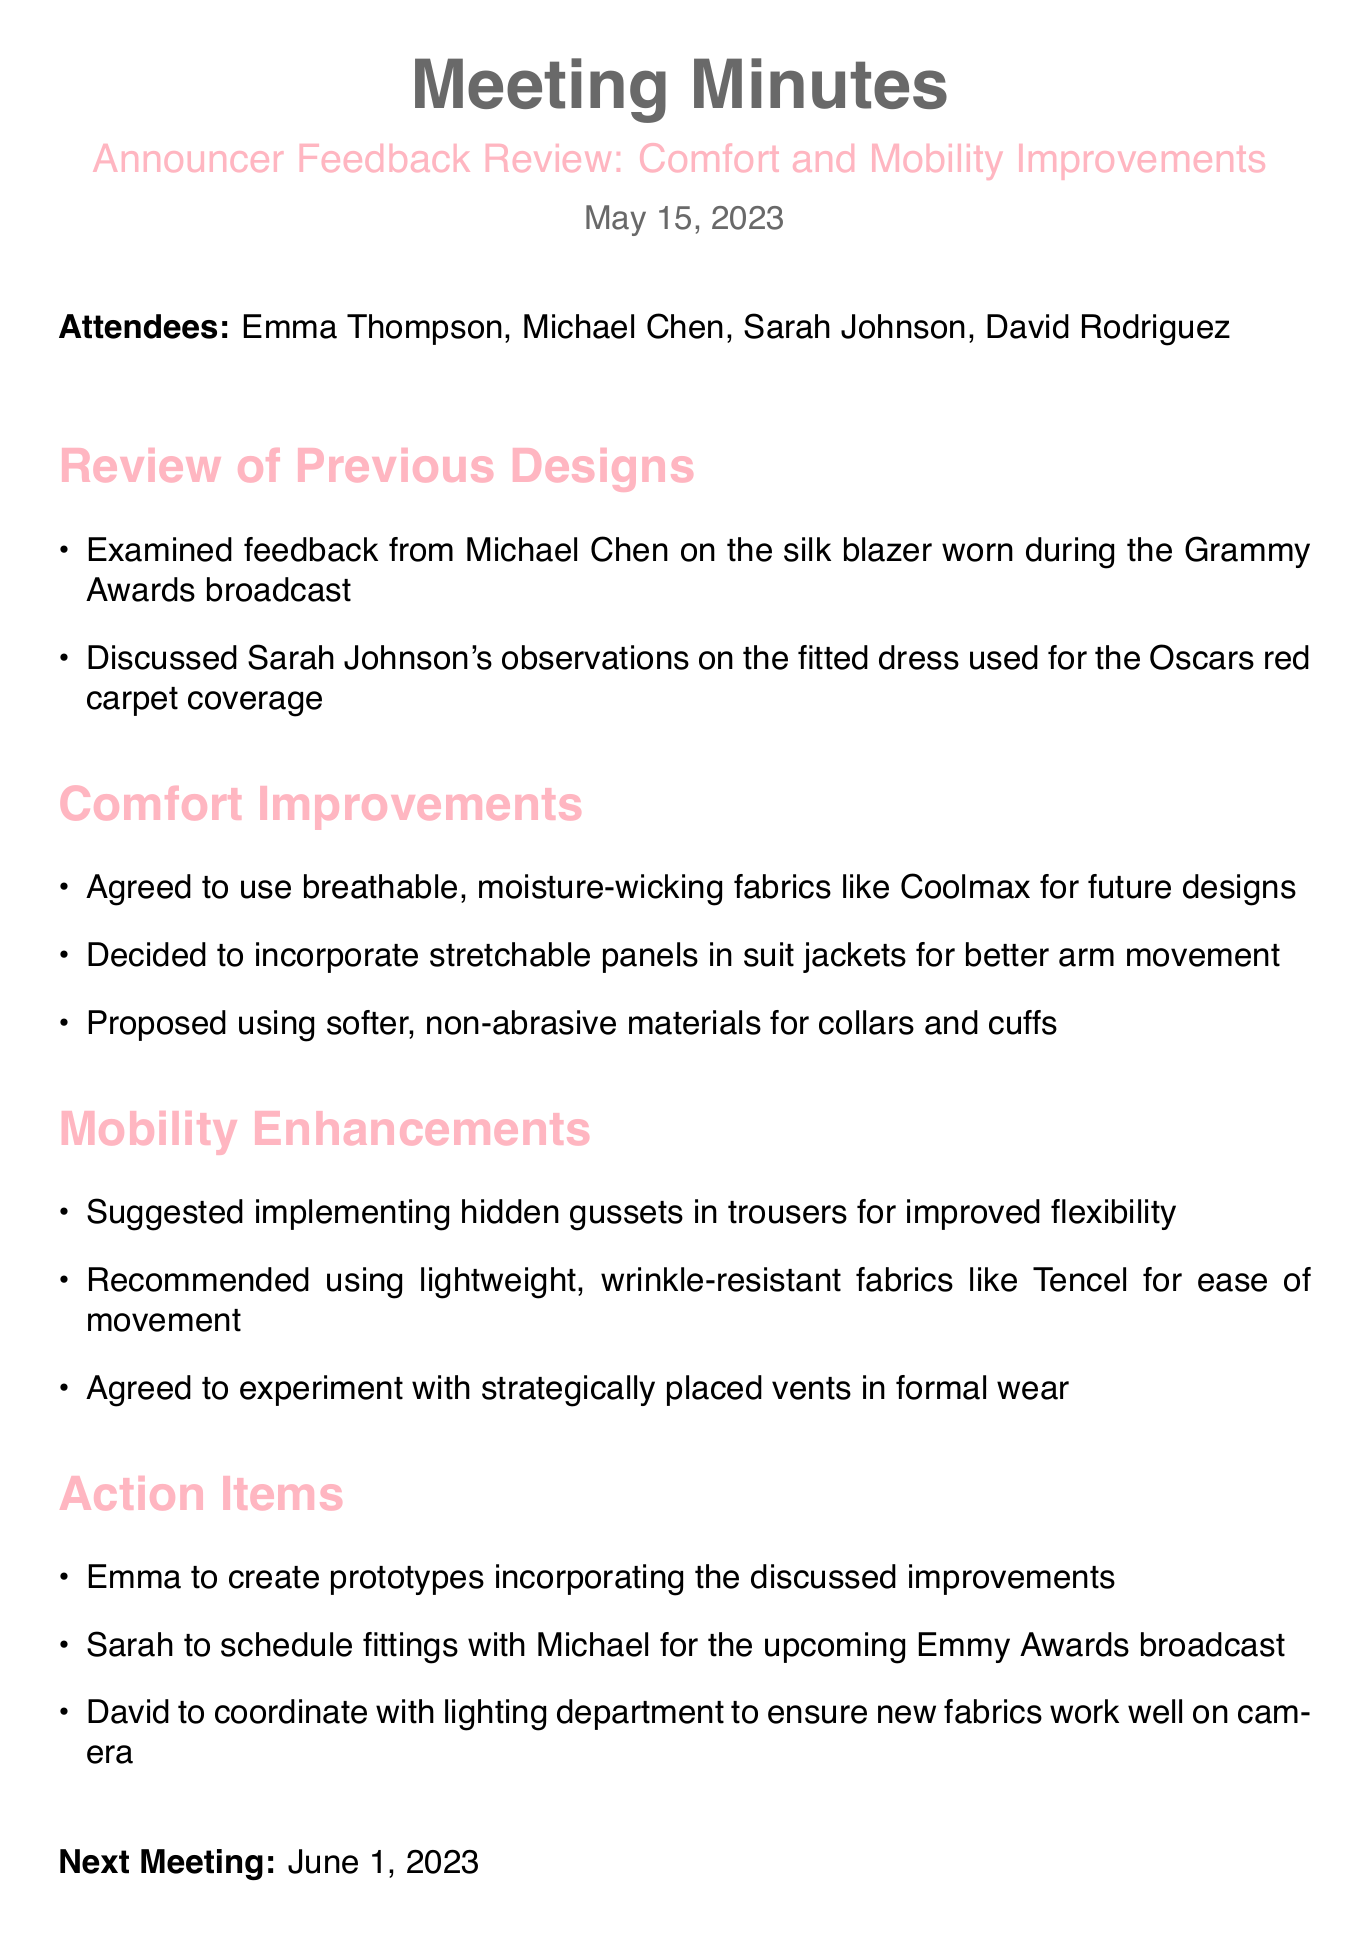What is the meeting title? The meeting title is indicated at the top of the document, specifying the main focus of the meeting.
Answer: Announcer Feedback Review: Comfort and Mobility Improvements Who is the lead announcer? The lead announcer is mentioned in the list of attendees, denoting their role in the meeting.
Answer: Michael Chen What date was the meeting held? The date is provided at the beginning of the document, indicating when the meeting took place.
Answer: May 15, 2023 Which fabric is agreed to be used for future designs? The specific fabric mentioned for comfort improvements is noted in the section detailing the agreed fabric choices.
Answer: Coolmax What mobility enhancement was suggested for trousers? This is detailed in the mobility enhancements section, indicating a specific improvement to allow for better movement.
Answer: Hidden gussets Who is responsible for creating prototypes? The action item outlines the responsibilities assigned to attendees, specifying who will create the prototypes.
Answer: Emma What is the next meeting date? This information is given at the end of the document, indicating when the follow-up meeting will occur.
Answer: June 1, 2023 What type of materials is proposed for collars and cuffs? The comfort improvements section specifically mentions the type of materials to be used for collars and cuffs.
Answer: Softer, non-abrasive materials How many attendees were present at the meeting? The number of attendees can be deduced from the list provided at the beginning of the document.
Answer: Four 